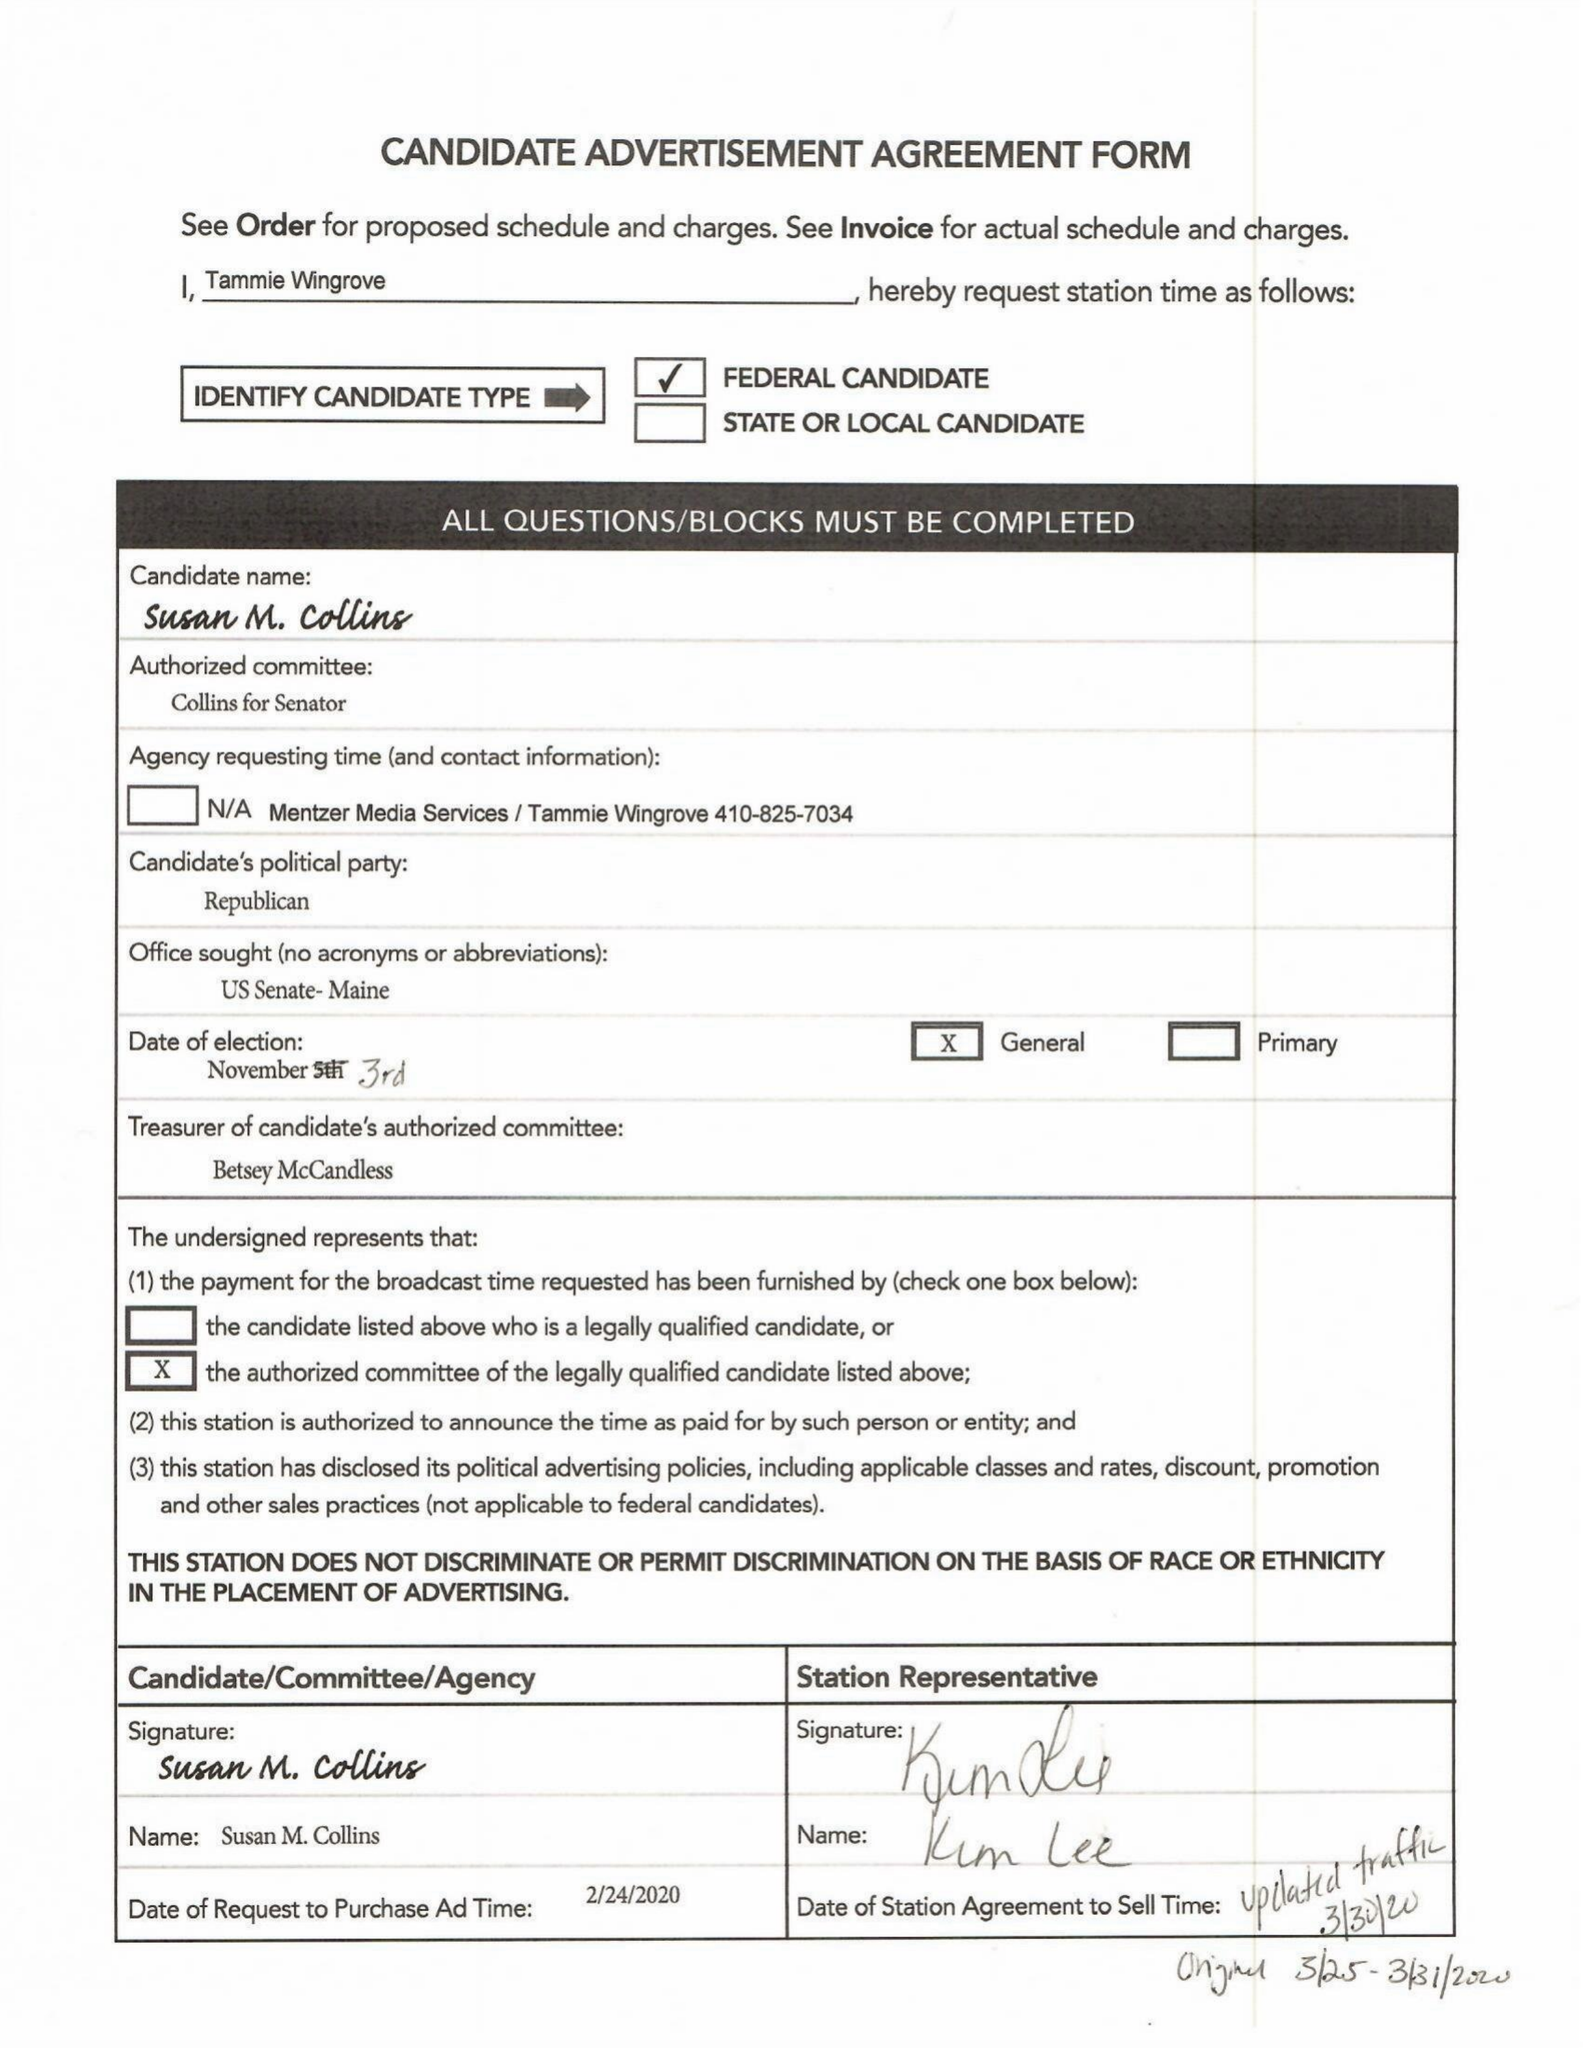What is the value for the advertiser?
Answer the question using a single word or phrase. None 